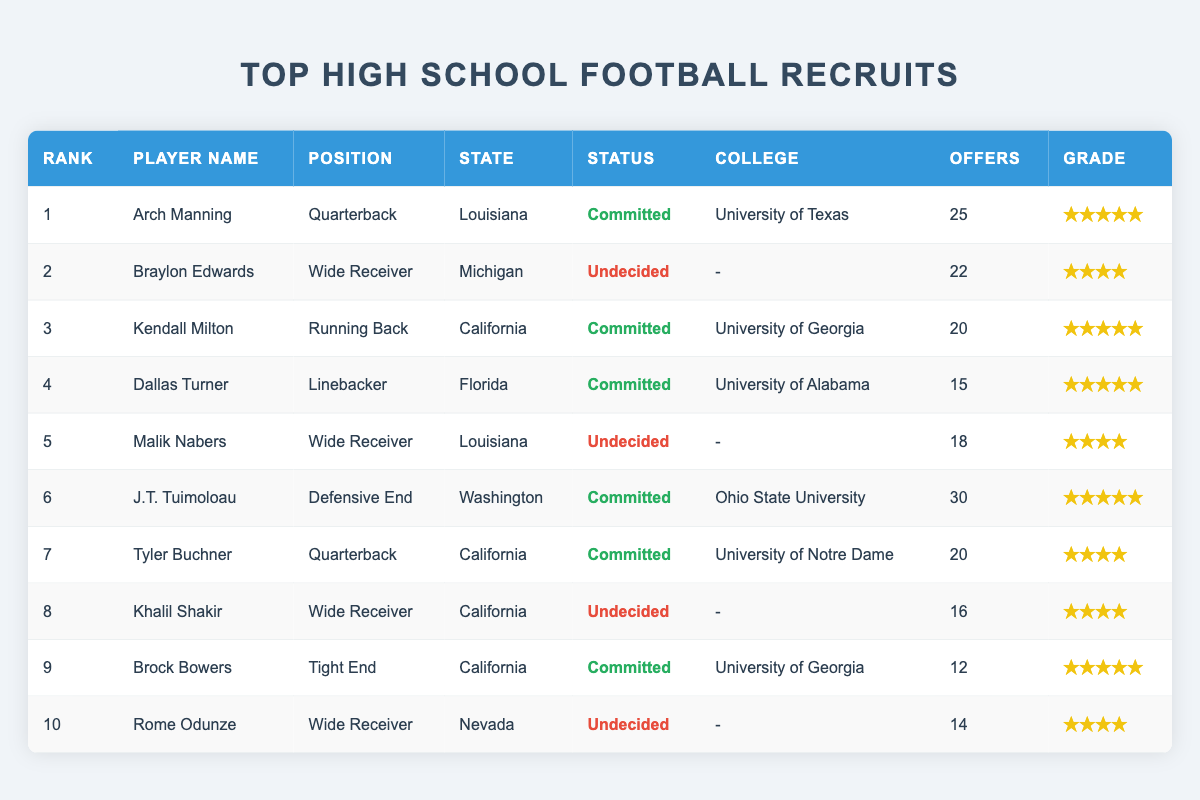What is the highest recruitment rank in the table? The highest recruitment rank listed in the table is found in the first row, where the player's rank is 1.
Answer: 1 How many players are committed to colleges? By viewing the commitment statuses, we see that 6 players have a status of "Committed". These players can be clearly identified by their commitment status marked in green.
Answer: 6 What is the average number of offers for players who are undecided? There are 4 undecided players: Braylon Edwards (22 offers), Malik Nabers (18 offers), Khalil Shakir (16 offers), and Rome Odunze (14 offers). The total number of offers is 22 + 18 + 16 + 14 = 70. The average is 70/4 = 17.5.
Answer: 17.5 Which position has the most players listed in the table? Reviewing the positions, we find that "Wide Receiver" has 4 players (Braylon Edwards, Malik Nabers, Khalil Shakir, and Rome Odunze), which is more than any other position.
Answer: Wide Receiver Is there a player from Nevada who is committed? Looking through the table, Rome Odunze, who is from Nevada, has the status "Undecided", indicating that he has not committed to any college.
Answer: No Which college has the highest number of players committed? Sorting through the colleges and their respective committed players, the University of Georgia has 2 committed players (Kendall Milton and Brock Bowers), more than any other college.
Answer: University of Georgia What is the total number of offers for players who are committed? By summing up the offers for the 6 committed players: 25 (Arch Manning) + 20 (Kendall Milton) + 15 (Dallas Turner) + 30 (J.T. Tuimoloau) + 20 (Tyler Buchner) + 12 (Brock Bowers) gives a total of 132 offers.
Answer: 132 Which state has the most represented players in the table? By analyzing the states, California has 4 players (Kendall Milton, Tyler Buchner, Khalil Shakir, and Brock Bowers), which is more than any other state.
Answer: California What is the scouting grade of the player with the most offers? The player with the most offers is J.T. Tuimoloau, who has a total of 30 offers. His scouting grade is a 5-star.
Answer: 5-star Are there any players with the same scouting grade? Yes, both Malik Nabers and Khalil Shakir received the same scouting grade of 4-star.
Answer: Yes 